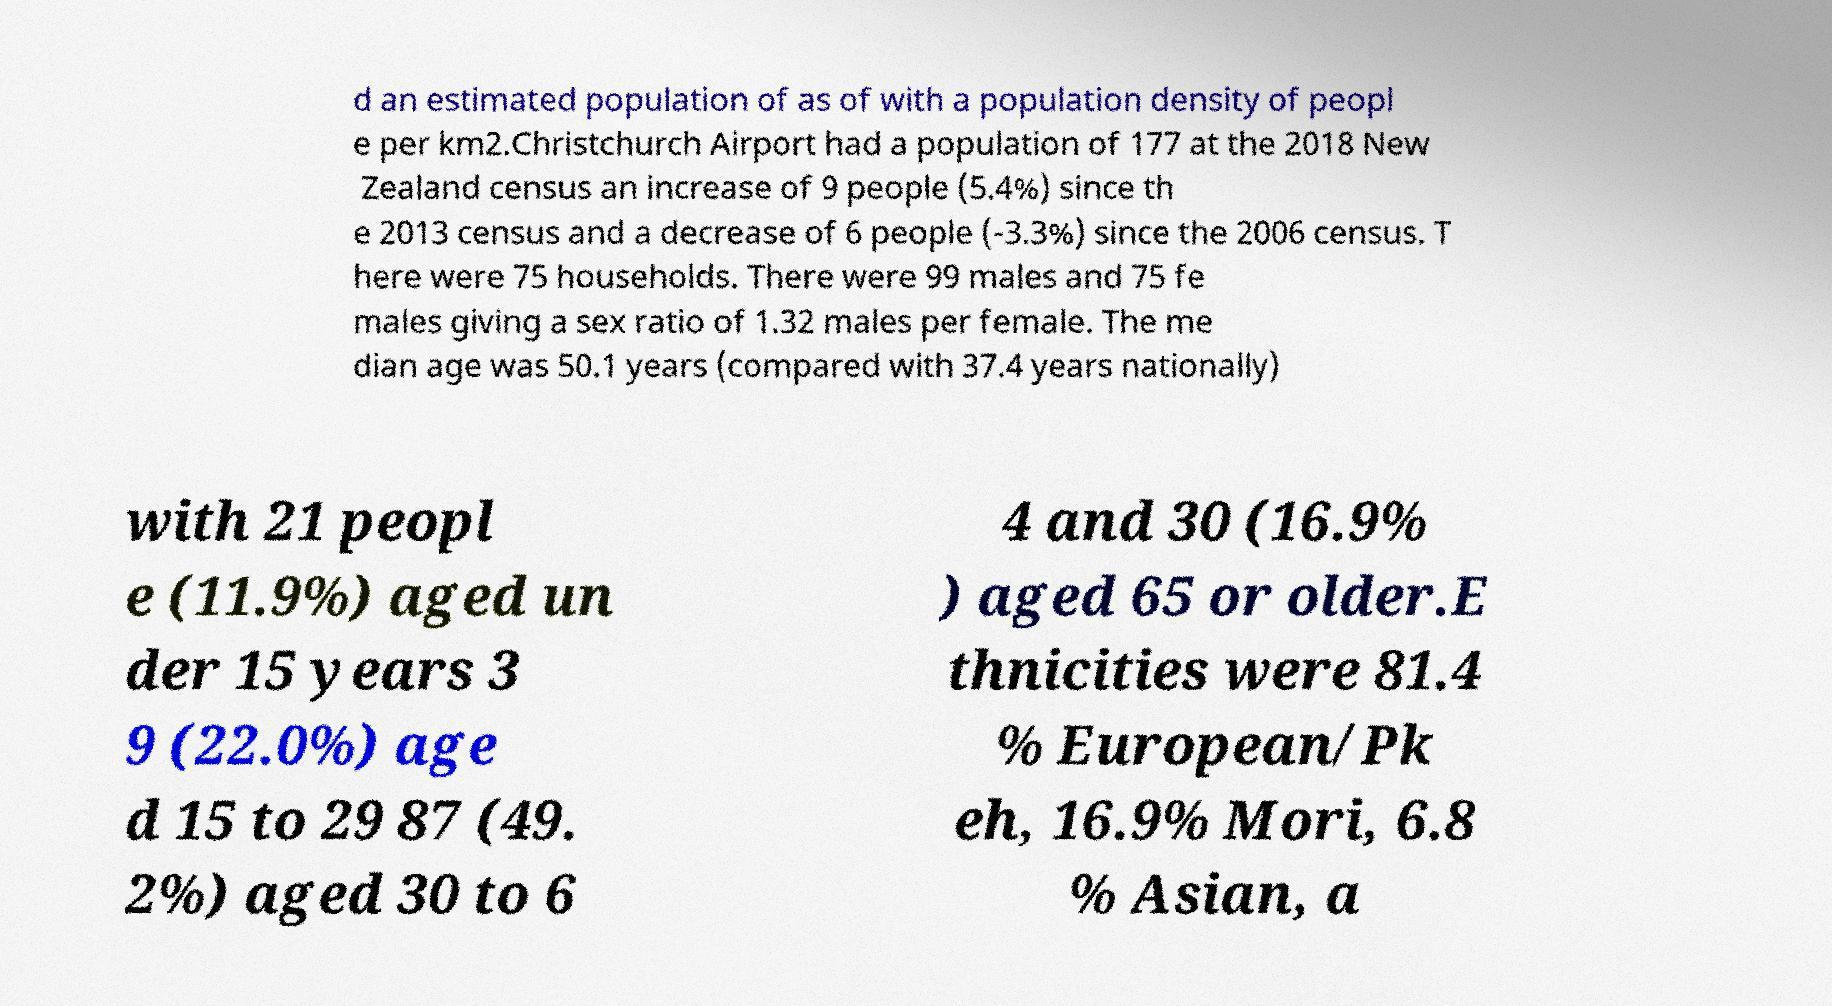What messages or text are displayed in this image? I need them in a readable, typed format. d an estimated population of as of with a population density of peopl e per km2.Christchurch Airport had a population of 177 at the 2018 New Zealand census an increase of 9 people (5.4%) since th e 2013 census and a decrease of 6 people (-3.3%) since the 2006 census. T here were 75 households. There were 99 males and 75 fe males giving a sex ratio of 1.32 males per female. The me dian age was 50.1 years (compared with 37.4 years nationally) with 21 peopl e (11.9%) aged un der 15 years 3 9 (22.0%) age d 15 to 29 87 (49. 2%) aged 30 to 6 4 and 30 (16.9% ) aged 65 or older.E thnicities were 81.4 % European/Pk eh, 16.9% Mori, 6.8 % Asian, a 